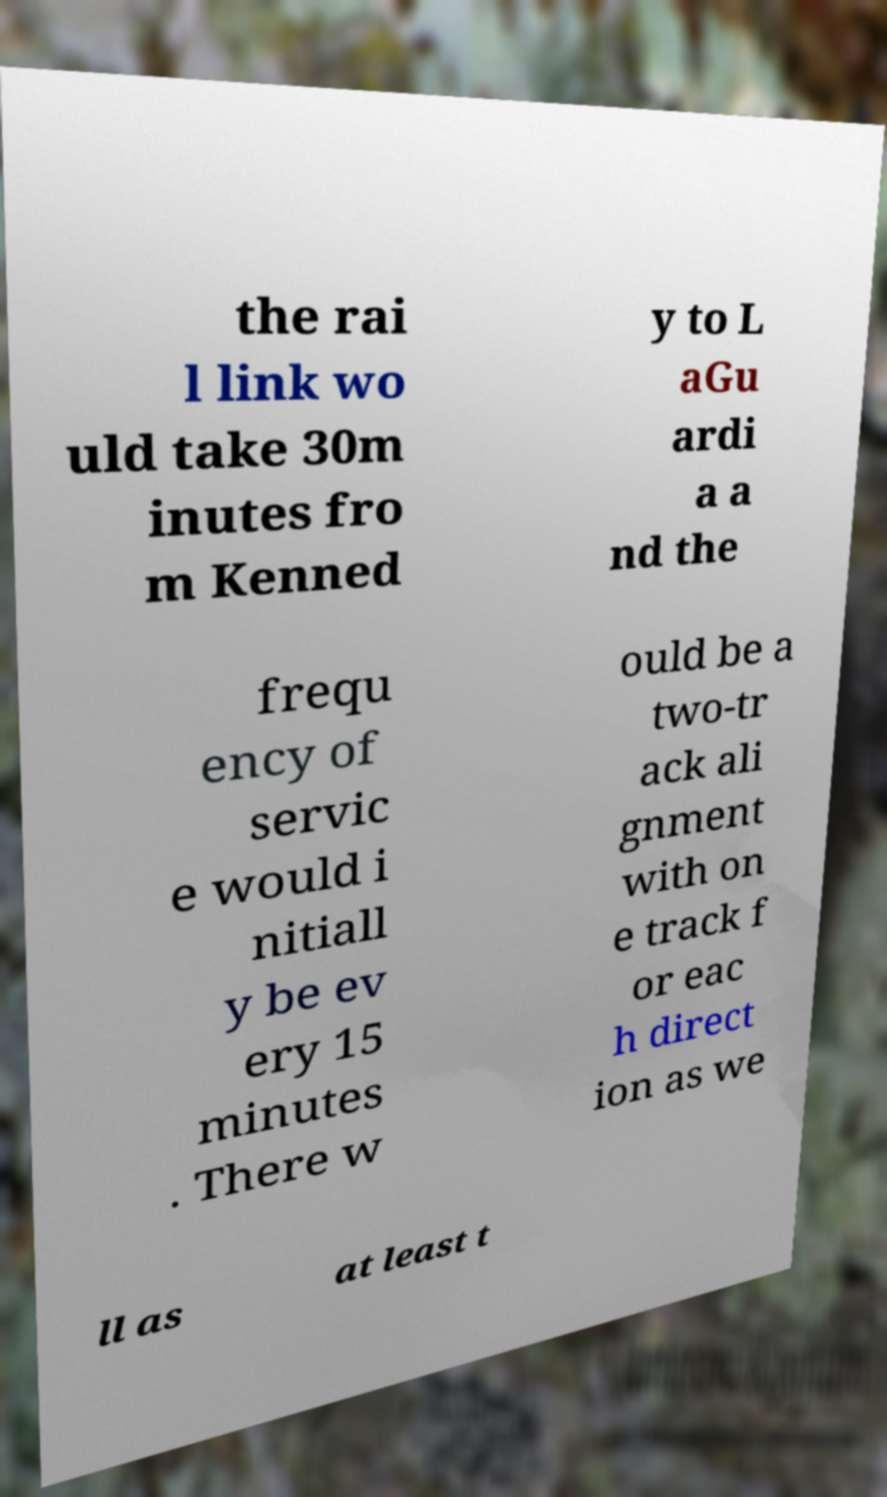I need the written content from this picture converted into text. Can you do that? the rai l link wo uld take 30m inutes fro m Kenned y to L aGu ardi a a nd the frequ ency of servic e would i nitiall y be ev ery 15 minutes . There w ould be a two-tr ack ali gnment with on e track f or eac h direct ion as we ll as at least t 